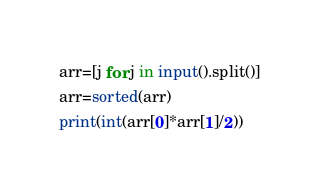<code> <loc_0><loc_0><loc_500><loc_500><_Python_>arr=[j for j in input().split()]
arr=sorted(arr)
print(int(arr[0]*arr[1]/2))</code> 